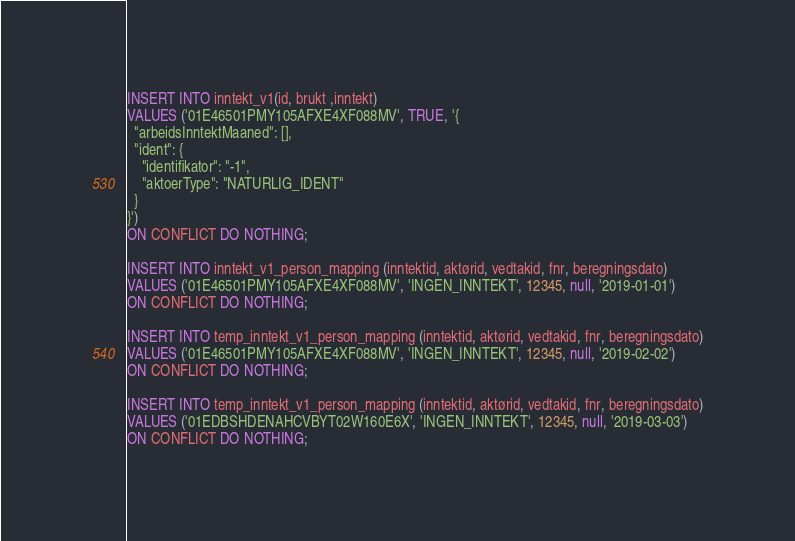Convert code to text. <code><loc_0><loc_0><loc_500><loc_500><_SQL_>INSERT INTO inntekt_v1(id, brukt ,inntekt)
VALUES ('01E46501PMY105AFXE4XF088MV', TRUE, '{
  "arbeidsInntektMaaned": [],
  "ident": {
    "identifikator": "-1",
    "aktoerType": "NATURLIG_IDENT"
  }
}')
ON CONFLICT DO NOTHING;

INSERT INTO inntekt_v1_person_mapping (inntektid, aktørid, vedtakid, fnr, beregningsdato)
VALUES ('01E46501PMY105AFXE4XF088MV', 'INGEN_INNTEKT', 12345, null, '2019-01-01')
ON CONFLICT DO NOTHING;

INSERT INTO temp_inntekt_v1_person_mapping (inntektid, aktørid, vedtakid, fnr, beregningsdato)
VALUES ('01E46501PMY105AFXE4XF088MV', 'INGEN_INNTEKT', 12345, null, '2019-02-02')
ON CONFLICT DO NOTHING;

INSERT INTO temp_inntekt_v1_person_mapping (inntektid, aktørid, vedtakid, fnr, beregningsdato)
VALUES ('01EDBSHDENAHCVBYT02W160E6X', 'INGEN_INNTEKT', 12345, null, '2019-03-03')
ON CONFLICT DO NOTHING;
</code> 